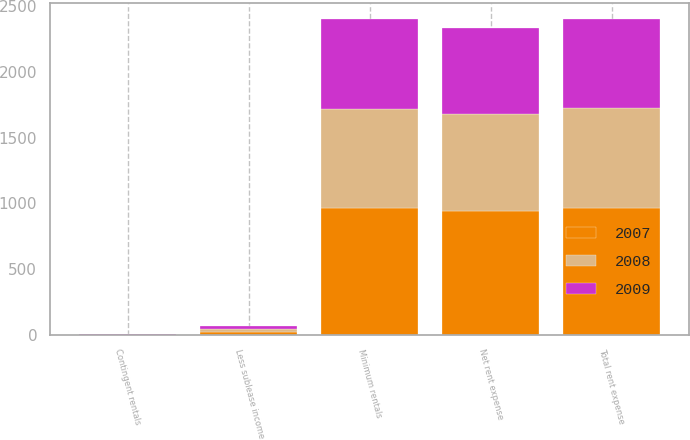<chart> <loc_0><loc_0><loc_500><loc_500><stacked_bar_chart><ecel><fcel>Minimum rentals<fcel>Contingent rentals<fcel>Total rent expense<fcel>Less sublease income<fcel>Net rent expense<nl><fcel>2007<fcel>962<fcel>1<fcel>963<fcel>23<fcel>940<nl><fcel>2008<fcel>757<fcel>1<fcel>758<fcel>22<fcel>736<nl><fcel>2009<fcel>679<fcel>1<fcel>680<fcel>20<fcel>660<nl></chart> 